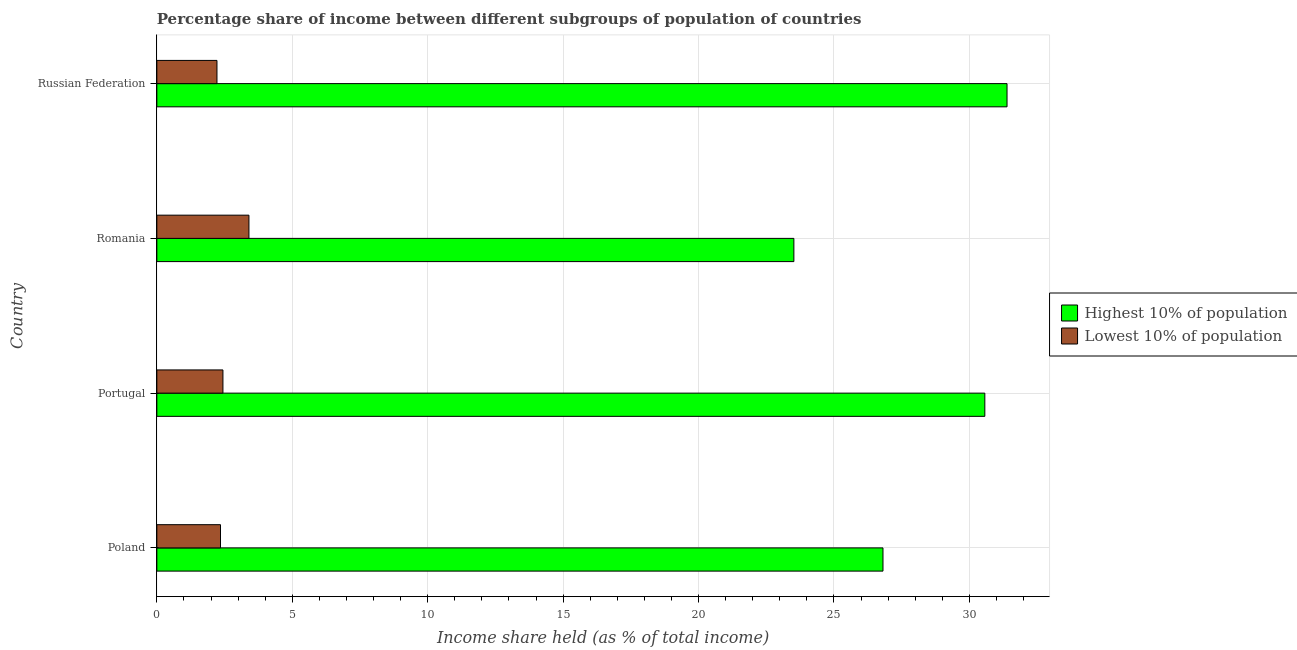How many different coloured bars are there?
Ensure brevity in your answer.  2. How many groups of bars are there?
Ensure brevity in your answer.  4. Are the number of bars on each tick of the Y-axis equal?
Your answer should be very brief. Yes. What is the label of the 2nd group of bars from the top?
Make the answer very short. Romania. What is the income share held by highest 10% of the population in Portugal?
Make the answer very short. 30.57. Across all countries, what is the maximum income share held by highest 10% of the population?
Offer a very short reply. 31.39. Across all countries, what is the minimum income share held by lowest 10% of the population?
Make the answer very short. 2.22. In which country was the income share held by lowest 10% of the population maximum?
Your answer should be very brief. Romania. In which country was the income share held by lowest 10% of the population minimum?
Offer a very short reply. Russian Federation. What is the total income share held by highest 10% of the population in the graph?
Your response must be concise. 112.29. What is the difference between the income share held by highest 10% of the population in Portugal and that in Russian Federation?
Make the answer very short. -0.82. What is the difference between the income share held by lowest 10% of the population in Poland and the income share held by highest 10% of the population in Portugal?
Offer a very short reply. -28.22. What is the average income share held by lowest 10% of the population per country?
Provide a short and direct response. 2.6. What is the difference between the income share held by highest 10% of the population and income share held by lowest 10% of the population in Poland?
Your answer should be very brief. 24.46. What is the ratio of the income share held by lowest 10% of the population in Portugal to that in Russian Federation?
Provide a short and direct response. 1.1. Is the income share held by highest 10% of the population in Portugal less than that in Russian Federation?
Offer a terse response. Yes. What is the difference between the highest and the second highest income share held by highest 10% of the population?
Make the answer very short. 0.82. What is the difference between the highest and the lowest income share held by lowest 10% of the population?
Ensure brevity in your answer.  1.18. In how many countries, is the income share held by highest 10% of the population greater than the average income share held by highest 10% of the population taken over all countries?
Offer a terse response. 2. Is the sum of the income share held by highest 10% of the population in Poland and Russian Federation greater than the maximum income share held by lowest 10% of the population across all countries?
Offer a very short reply. Yes. What does the 2nd bar from the top in Russian Federation represents?
Keep it short and to the point. Highest 10% of population. What does the 1st bar from the bottom in Portugal represents?
Make the answer very short. Highest 10% of population. Are the values on the major ticks of X-axis written in scientific E-notation?
Your answer should be compact. No. Does the graph contain any zero values?
Provide a short and direct response. No. Does the graph contain grids?
Your answer should be compact. Yes. How many legend labels are there?
Provide a succinct answer. 2. What is the title of the graph?
Offer a terse response. Percentage share of income between different subgroups of population of countries. Does "Secondary education" appear as one of the legend labels in the graph?
Keep it short and to the point. No. What is the label or title of the X-axis?
Provide a succinct answer. Income share held (as % of total income). What is the Income share held (as % of total income) of Highest 10% of population in Poland?
Offer a very short reply. 26.81. What is the Income share held (as % of total income) of Lowest 10% of population in Poland?
Make the answer very short. 2.35. What is the Income share held (as % of total income) of Highest 10% of population in Portugal?
Offer a very short reply. 30.57. What is the Income share held (as % of total income) in Lowest 10% of population in Portugal?
Your answer should be compact. 2.44. What is the Income share held (as % of total income) of Highest 10% of population in Romania?
Make the answer very short. 23.52. What is the Income share held (as % of total income) in Highest 10% of population in Russian Federation?
Your response must be concise. 31.39. What is the Income share held (as % of total income) of Lowest 10% of population in Russian Federation?
Your answer should be very brief. 2.22. Across all countries, what is the maximum Income share held (as % of total income) of Highest 10% of population?
Give a very brief answer. 31.39. Across all countries, what is the maximum Income share held (as % of total income) in Lowest 10% of population?
Your answer should be compact. 3.4. Across all countries, what is the minimum Income share held (as % of total income) in Highest 10% of population?
Your answer should be compact. 23.52. Across all countries, what is the minimum Income share held (as % of total income) of Lowest 10% of population?
Make the answer very short. 2.22. What is the total Income share held (as % of total income) of Highest 10% of population in the graph?
Your answer should be very brief. 112.29. What is the total Income share held (as % of total income) of Lowest 10% of population in the graph?
Give a very brief answer. 10.41. What is the difference between the Income share held (as % of total income) in Highest 10% of population in Poland and that in Portugal?
Your answer should be compact. -3.76. What is the difference between the Income share held (as % of total income) in Lowest 10% of population in Poland and that in Portugal?
Make the answer very short. -0.09. What is the difference between the Income share held (as % of total income) in Highest 10% of population in Poland and that in Romania?
Keep it short and to the point. 3.29. What is the difference between the Income share held (as % of total income) in Lowest 10% of population in Poland and that in Romania?
Your response must be concise. -1.05. What is the difference between the Income share held (as % of total income) of Highest 10% of population in Poland and that in Russian Federation?
Your response must be concise. -4.58. What is the difference between the Income share held (as % of total income) in Lowest 10% of population in Poland and that in Russian Federation?
Offer a very short reply. 0.13. What is the difference between the Income share held (as % of total income) in Highest 10% of population in Portugal and that in Romania?
Provide a succinct answer. 7.05. What is the difference between the Income share held (as % of total income) of Lowest 10% of population in Portugal and that in Romania?
Give a very brief answer. -0.96. What is the difference between the Income share held (as % of total income) in Highest 10% of population in Portugal and that in Russian Federation?
Provide a succinct answer. -0.82. What is the difference between the Income share held (as % of total income) of Lowest 10% of population in Portugal and that in Russian Federation?
Give a very brief answer. 0.22. What is the difference between the Income share held (as % of total income) of Highest 10% of population in Romania and that in Russian Federation?
Give a very brief answer. -7.87. What is the difference between the Income share held (as % of total income) of Lowest 10% of population in Romania and that in Russian Federation?
Provide a short and direct response. 1.18. What is the difference between the Income share held (as % of total income) of Highest 10% of population in Poland and the Income share held (as % of total income) of Lowest 10% of population in Portugal?
Provide a short and direct response. 24.37. What is the difference between the Income share held (as % of total income) in Highest 10% of population in Poland and the Income share held (as % of total income) in Lowest 10% of population in Romania?
Ensure brevity in your answer.  23.41. What is the difference between the Income share held (as % of total income) in Highest 10% of population in Poland and the Income share held (as % of total income) in Lowest 10% of population in Russian Federation?
Keep it short and to the point. 24.59. What is the difference between the Income share held (as % of total income) of Highest 10% of population in Portugal and the Income share held (as % of total income) of Lowest 10% of population in Romania?
Your answer should be very brief. 27.17. What is the difference between the Income share held (as % of total income) in Highest 10% of population in Portugal and the Income share held (as % of total income) in Lowest 10% of population in Russian Federation?
Give a very brief answer. 28.35. What is the difference between the Income share held (as % of total income) in Highest 10% of population in Romania and the Income share held (as % of total income) in Lowest 10% of population in Russian Federation?
Provide a succinct answer. 21.3. What is the average Income share held (as % of total income) in Highest 10% of population per country?
Your answer should be compact. 28.07. What is the average Income share held (as % of total income) of Lowest 10% of population per country?
Provide a short and direct response. 2.6. What is the difference between the Income share held (as % of total income) in Highest 10% of population and Income share held (as % of total income) in Lowest 10% of population in Poland?
Offer a terse response. 24.46. What is the difference between the Income share held (as % of total income) in Highest 10% of population and Income share held (as % of total income) in Lowest 10% of population in Portugal?
Offer a very short reply. 28.13. What is the difference between the Income share held (as % of total income) in Highest 10% of population and Income share held (as % of total income) in Lowest 10% of population in Romania?
Keep it short and to the point. 20.12. What is the difference between the Income share held (as % of total income) of Highest 10% of population and Income share held (as % of total income) of Lowest 10% of population in Russian Federation?
Your answer should be very brief. 29.17. What is the ratio of the Income share held (as % of total income) of Highest 10% of population in Poland to that in Portugal?
Ensure brevity in your answer.  0.88. What is the ratio of the Income share held (as % of total income) in Lowest 10% of population in Poland to that in Portugal?
Keep it short and to the point. 0.96. What is the ratio of the Income share held (as % of total income) in Highest 10% of population in Poland to that in Romania?
Your answer should be compact. 1.14. What is the ratio of the Income share held (as % of total income) in Lowest 10% of population in Poland to that in Romania?
Your answer should be very brief. 0.69. What is the ratio of the Income share held (as % of total income) in Highest 10% of population in Poland to that in Russian Federation?
Offer a very short reply. 0.85. What is the ratio of the Income share held (as % of total income) of Lowest 10% of population in Poland to that in Russian Federation?
Provide a short and direct response. 1.06. What is the ratio of the Income share held (as % of total income) of Highest 10% of population in Portugal to that in Romania?
Keep it short and to the point. 1.3. What is the ratio of the Income share held (as % of total income) of Lowest 10% of population in Portugal to that in Romania?
Your answer should be very brief. 0.72. What is the ratio of the Income share held (as % of total income) in Highest 10% of population in Portugal to that in Russian Federation?
Your answer should be compact. 0.97. What is the ratio of the Income share held (as % of total income) of Lowest 10% of population in Portugal to that in Russian Federation?
Offer a terse response. 1.1. What is the ratio of the Income share held (as % of total income) of Highest 10% of population in Romania to that in Russian Federation?
Your answer should be very brief. 0.75. What is the ratio of the Income share held (as % of total income) of Lowest 10% of population in Romania to that in Russian Federation?
Make the answer very short. 1.53. What is the difference between the highest and the second highest Income share held (as % of total income) in Highest 10% of population?
Your response must be concise. 0.82. What is the difference between the highest and the lowest Income share held (as % of total income) in Highest 10% of population?
Your answer should be compact. 7.87. What is the difference between the highest and the lowest Income share held (as % of total income) in Lowest 10% of population?
Offer a terse response. 1.18. 